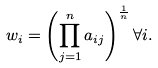Convert formula to latex. <formula><loc_0><loc_0><loc_500><loc_500>w _ { i } = \left ( \prod _ { j = 1 } ^ { n } a _ { i j } \right ) ^ { \frac { 1 } { n } } \forall i .</formula> 